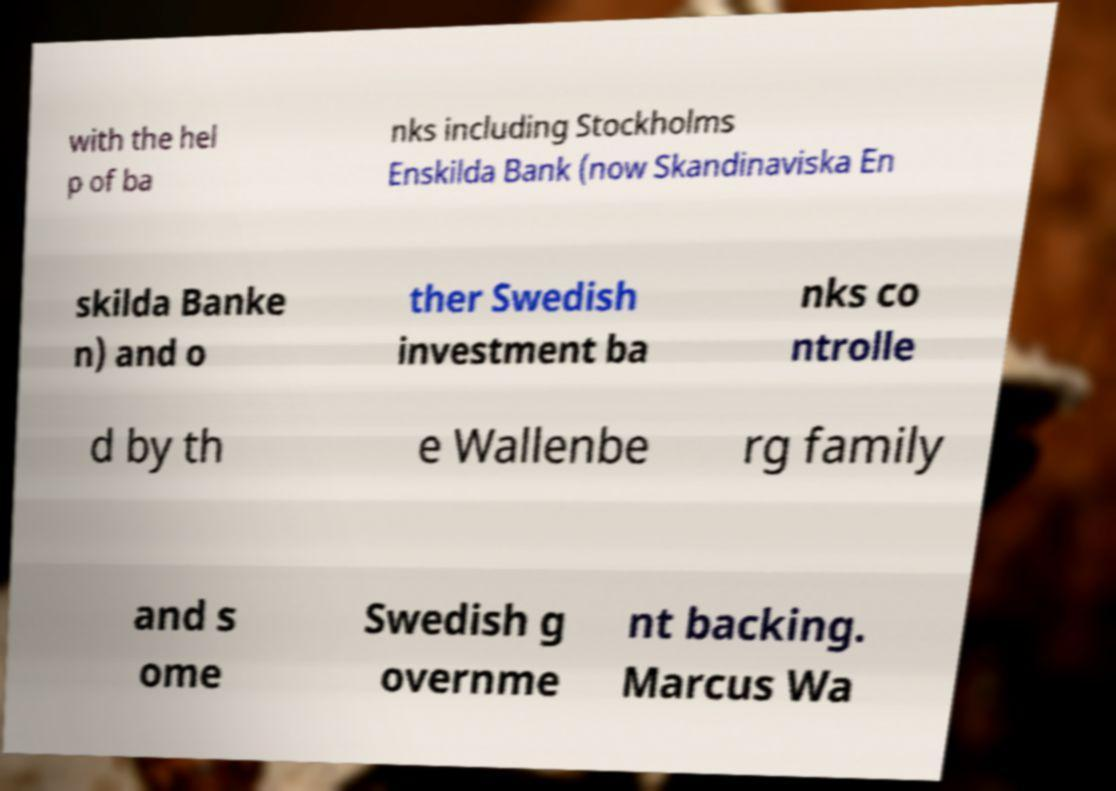For documentation purposes, I need the text within this image transcribed. Could you provide that? with the hel p of ba nks including Stockholms Enskilda Bank (now Skandinaviska En skilda Banke n) and o ther Swedish investment ba nks co ntrolle d by th e Wallenbe rg family and s ome Swedish g overnme nt backing. Marcus Wa 